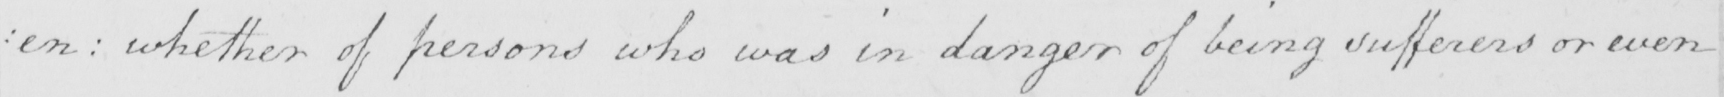Please provide the text content of this handwritten line. : en  :  whether of persons who was in danger of being sufferers or even 